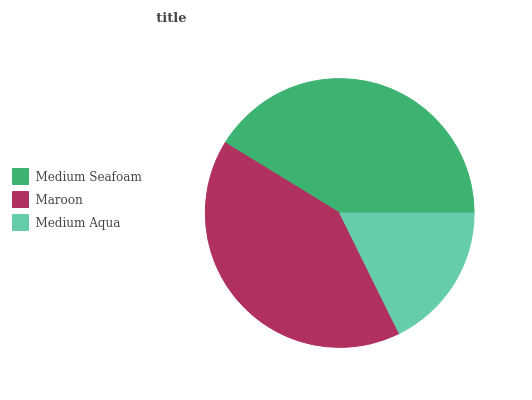Is Medium Aqua the minimum?
Answer yes or no. Yes. Is Medium Seafoam the maximum?
Answer yes or no. Yes. Is Maroon the minimum?
Answer yes or no. No. Is Maroon the maximum?
Answer yes or no. No. Is Medium Seafoam greater than Maroon?
Answer yes or no. Yes. Is Maroon less than Medium Seafoam?
Answer yes or no. Yes. Is Maroon greater than Medium Seafoam?
Answer yes or no. No. Is Medium Seafoam less than Maroon?
Answer yes or no. No. Is Maroon the high median?
Answer yes or no. Yes. Is Maroon the low median?
Answer yes or no. Yes. Is Medium Seafoam the high median?
Answer yes or no. No. Is Medium Aqua the low median?
Answer yes or no. No. 